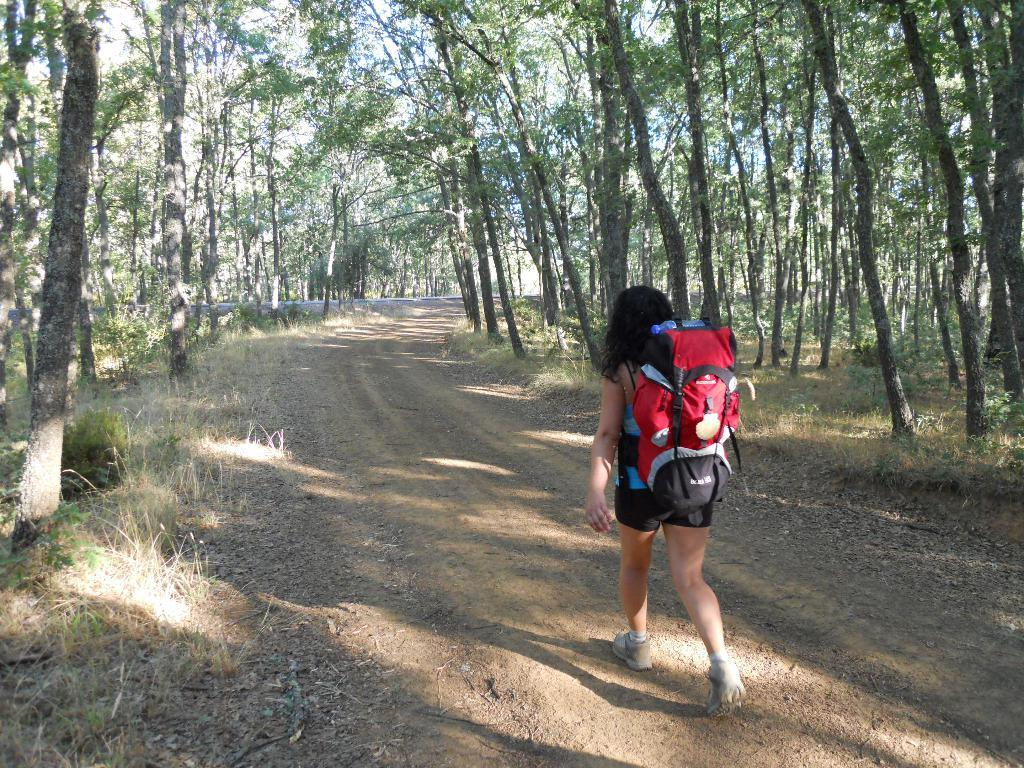Who is the main subject in the image? There is a woman in the image. What is the woman carrying on her back? The woman is wearing a backpack. What is the woman doing in the image? The woman is walking on a path. What type of terrain is visible in the image? Grass is visible on the ground. What can be seen on both sides of the path? There are trees visible on the left side and the right side of the path. What type of engine can be seen powering the woman's movement in the image? There is no engine present in the image; the woman is walking on her own. How many oranges are hanging from the trees on the left side of the path? There are no oranges visible in the image; only trees are present. 